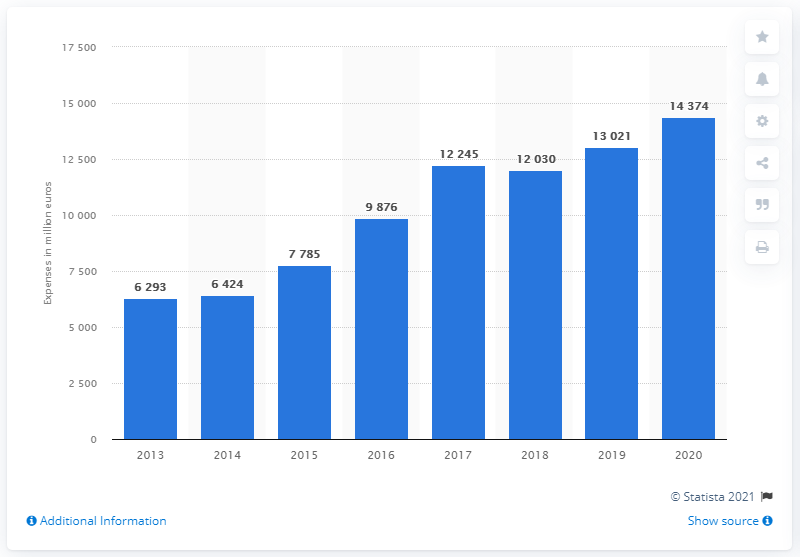Identify some key points in this picture. As of 2020, Peapod and Giant reported a total of $14,374 in selling expenses. The previous year's selling expenses were 13021. 